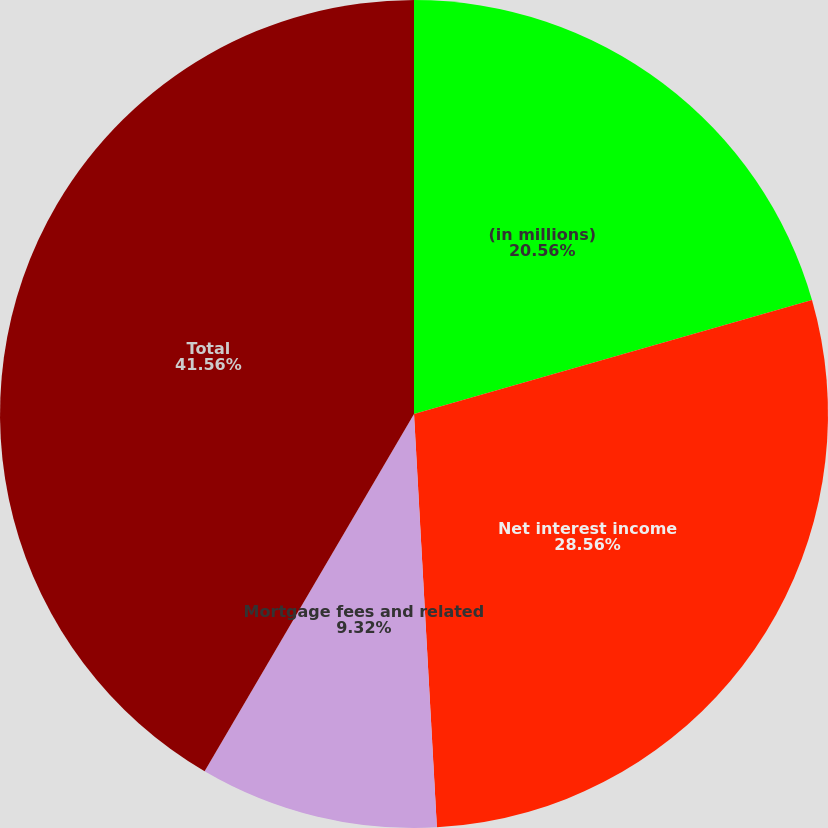<chart> <loc_0><loc_0><loc_500><loc_500><pie_chart><fcel>(in millions)<fcel>Net interest income<fcel>Mortgage fees and related<fcel>Total<nl><fcel>20.56%<fcel>28.56%<fcel>9.32%<fcel>41.56%<nl></chart> 